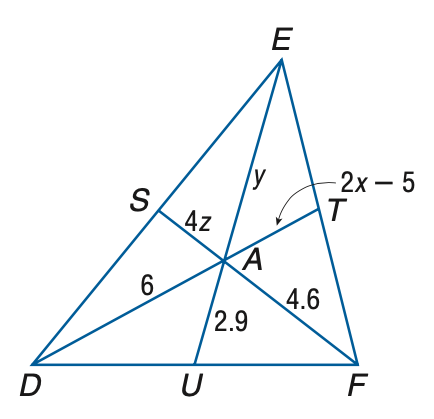Question: Points S, T, and U are the midpoints of D E, E F, and D F, respectively. Find y.
Choices:
A. 2.9
B. 4.0
C. 4.6
D. 5.8
Answer with the letter. Answer: D Question: Points S, T, and U are the midpoints of D E, E F, and D F, respectively. Find z.
Choices:
A. 0.383
B. 0.575
C. 1.15
D. 2.875
Answer with the letter. Answer: B Question: Points S, T, and U are the midpoints of D E, E F, and D F, respectively. Find x.
Choices:
A. 4
B. 4.5
C. 5
D. 5.5
Answer with the letter. Answer: A 